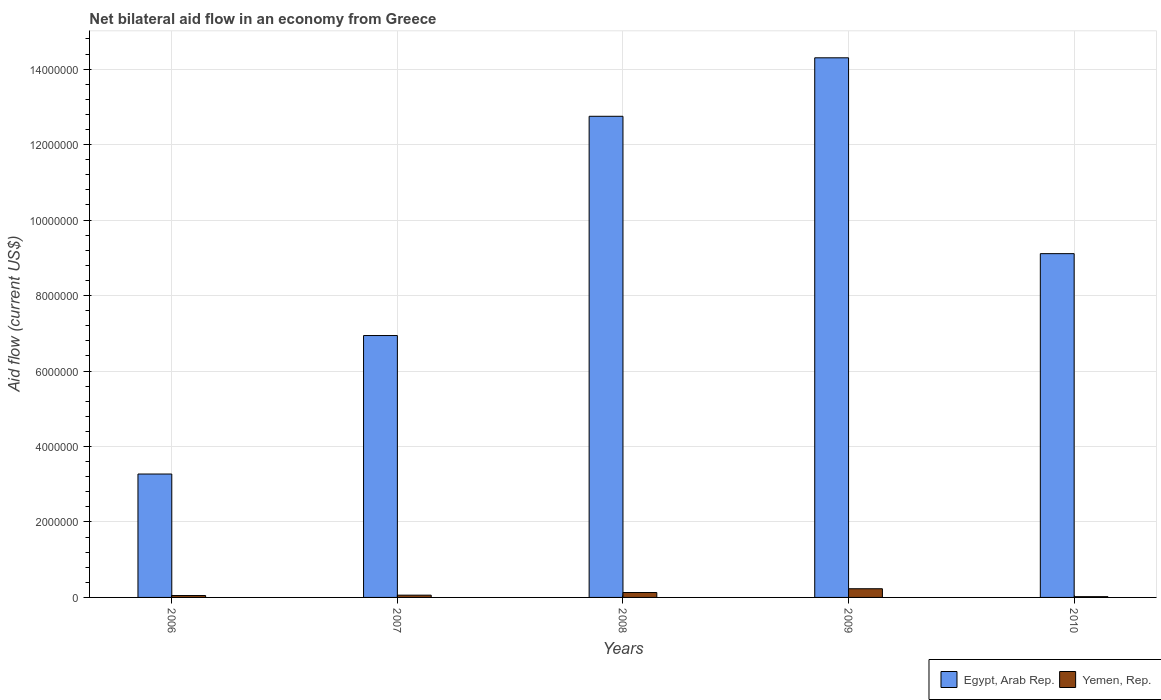How many different coloured bars are there?
Make the answer very short. 2. How many groups of bars are there?
Your answer should be compact. 5. Are the number of bars per tick equal to the number of legend labels?
Your response must be concise. Yes. How many bars are there on the 1st tick from the left?
Your response must be concise. 2. What is the label of the 4th group of bars from the left?
Offer a very short reply. 2009. What is the net bilateral aid flow in Egypt, Arab Rep. in 2008?
Your response must be concise. 1.28e+07. Across all years, what is the maximum net bilateral aid flow in Egypt, Arab Rep.?
Make the answer very short. 1.43e+07. Across all years, what is the minimum net bilateral aid flow in Egypt, Arab Rep.?
Offer a terse response. 3.27e+06. In which year was the net bilateral aid flow in Egypt, Arab Rep. maximum?
Offer a very short reply. 2009. In which year was the net bilateral aid flow in Egypt, Arab Rep. minimum?
Ensure brevity in your answer.  2006. What is the total net bilateral aid flow in Egypt, Arab Rep. in the graph?
Your answer should be compact. 4.64e+07. What is the difference between the net bilateral aid flow in Egypt, Arab Rep. in 2007 and that in 2009?
Offer a very short reply. -7.36e+06. What is the difference between the net bilateral aid flow in Yemen, Rep. in 2008 and the net bilateral aid flow in Egypt, Arab Rep. in 2010?
Offer a very short reply. -8.98e+06. What is the average net bilateral aid flow in Yemen, Rep. per year?
Give a very brief answer. 9.80e+04. In the year 2009, what is the difference between the net bilateral aid flow in Egypt, Arab Rep. and net bilateral aid flow in Yemen, Rep.?
Your answer should be very brief. 1.41e+07. In how many years, is the net bilateral aid flow in Yemen, Rep. greater than 3600000 US$?
Make the answer very short. 0. What is the ratio of the net bilateral aid flow in Egypt, Arab Rep. in 2007 to that in 2008?
Ensure brevity in your answer.  0.54. What is the difference between the highest and the second highest net bilateral aid flow in Yemen, Rep.?
Make the answer very short. 1.00e+05. In how many years, is the net bilateral aid flow in Yemen, Rep. greater than the average net bilateral aid flow in Yemen, Rep. taken over all years?
Ensure brevity in your answer.  2. Is the sum of the net bilateral aid flow in Egypt, Arab Rep. in 2006 and 2008 greater than the maximum net bilateral aid flow in Yemen, Rep. across all years?
Provide a short and direct response. Yes. What does the 2nd bar from the left in 2008 represents?
Ensure brevity in your answer.  Yemen, Rep. What does the 1st bar from the right in 2008 represents?
Your answer should be very brief. Yemen, Rep. How many years are there in the graph?
Give a very brief answer. 5. What is the difference between two consecutive major ticks on the Y-axis?
Provide a succinct answer. 2.00e+06. Where does the legend appear in the graph?
Give a very brief answer. Bottom right. How are the legend labels stacked?
Your answer should be compact. Horizontal. What is the title of the graph?
Your response must be concise. Net bilateral aid flow in an economy from Greece. Does "Haiti" appear as one of the legend labels in the graph?
Make the answer very short. No. What is the label or title of the Y-axis?
Offer a terse response. Aid flow (current US$). What is the Aid flow (current US$) of Egypt, Arab Rep. in 2006?
Offer a very short reply. 3.27e+06. What is the Aid flow (current US$) in Egypt, Arab Rep. in 2007?
Provide a short and direct response. 6.94e+06. What is the Aid flow (current US$) of Egypt, Arab Rep. in 2008?
Ensure brevity in your answer.  1.28e+07. What is the Aid flow (current US$) in Egypt, Arab Rep. in 2009?
Keep it short and to the point. 1.43e+07. What is the Aid flow (current US$) in Yemen, Rep. in 2009?
Your answer should be very brief. 2.30e+05. What is the Aid flow (current US$) in Egypt, Arab Rep. in 2010?
Give a very brief answer. 9.11e+06. Across all years, what is the maximum Aid flow (current US$) in Egypt, Arab Rep.?
Your answer should be compact. 1.43e+07. Across all years, what is the maximum Aid flow (current US$) of Yemen, Rep.?
Offer a very short reply. 2.30e+05. Across all years, what is the minimum Aid flow (current US$) of Egypt, Arab Rep.?
Offer a terse response. 3.27e+06. What is the total Aid flow (current US$) in Egypt, Arab Rep. in the graph?
Offer a very short reply. 4.64e+07. What is the total Aid flow (current US$) of Yemen, Rep. in the graph?
Your response must be concise. 4.90e+05. What is the difference between the Aid flow (current US$) in Egypt, Arab Rep. in 2006 and that in 2007?
Provide a short and direct response. -3.67e+06. What is the difference between the Aid flow (current US$) in Egypt, Arab Rep. in 2006 and that in 2008?
Ensure brevity in your answer.  -9.48e+06. What is the difference between the Aid flow (current US$) of Yemen, Rep. in 2006 and that in 2008?
Your response must be concise. -8.00e+04. What is the difference between the Aid flow (current US$) in Egypt, Arab Rep. in 2006 and that in 2009?
Offer a very short reply. -1.10e+07. What is the difference between the Aid flow (current US$) of Egypt, Arab Rep. in 2006 and that in 2010?
Make the answer very short. -5.84e+06. What is the difference between the Aid flow (current US$) in Egypt, Arab Rep. in 2007 and that in 2008?
Ensure brevity in your answer.  -5.81e+06. What is the difference between the Aid flow (current US$) in Yemen, Rep. in 2007 and that in 2008?
Keep it short and to the point. -7.00e+04. What is the difference between the Aid flow (current US$) of Egypt, Arab Rep. in 2007 and that in 2009?
Provide a short and direct response. -7.36e+06. What is the difference between the Aid flow (current US$) in Yemen, Rep. in 2007 and that in 2009?
Your answer should be very brief. -1.70e+05. What is the difference between the Aid flow (current US$) of Egypt, Arab Rep. in 2007 and that in 2010?
Your answer should be very brief. -2.17e+06. What is the difference between the Aid flow (current US$) of Yemen, Rep. in 2007 and that in 2010?
Your answer should be compact. 4.00e+04. What is the difference between the Aid flow (current US$) in Egypt, Arab Rep. in 2008 and that in 2009?
Make the answer very short. -1.55e+06. What is the difference between the Aid flow (current US$) of Egypt, Arab Rep. in 2008 and that in 2010?
Offer a very short reply. 3.64e+06. What is the difference between the Aid flow (current US$) of Egypt, Arab Rep. in 2009 and that in 2010?
Your answer should be very brief. 5.19e+06. What is the difference between the Aid flow (current US$) of Egypt, Arab Rep. in 2006 and the Aid flow (current US$) of Yemen, Rep. in 2007?
Provide a succinct answer. 3.21e+06. What is the difference between the Aid flow (current US$) in Egypt, Arab Rep. in 2006 and the Aid flow (current US$) in Yemen, Rep. in 2008?
Offer a terse response. 3.14e+06. What is the difference between the Aid flow (current US$) of Egypt, Arab Rep. in 2006 and the Aid flow (current US$) of Yemen, Rep. in 2009?
Give a very brief answer. 3.04e+06. What is the difference between the Aid flow (current US$) of Egypt, Arab Rep. in 2006 and the Aid flow (current US$) of Yemen, Rep. in 2010?
Provide a succinct answer. 3.25e+06. What is the difference between the Aid flow (current US$) in Egypt, Arab Rep. in 2007 and the Aid flow (current US$) in Yemen, Rep. in 2008?
Ensure brevity in your answer.  6.81e+06. What is the difference between the Aid flow (current US$) in Egypt, Arab Rep. in 2007 and the Aid flow (current US$) in Yemen, Rep. in 2009?
Provide a succinct answer. 6.71e+06. What is the difference between the Aid flow (current US$) of Egypt, Arab Rep. in 2007 and the Aid flow (current US$) of Yemen, Rep. in 2010?
Give a very brief answer. 6.92e+06. What is the difference between the Aid flow (current US$) of Egypt, Arab Rep. in 2008 and the Aid flow (current US$) of Yemen, Rep. in 2009?
Your answer should be very brief. 1.25e+07. What is the difference between the Aid flow (current US$) of Egypt, Arab Rep. in 2008 and the Aid flow (current US$) of Yemen, Rep. in 2010?
Your answer should be compact. 1.27e+07. What is the difference between the Aid flow (current US$) in Egypt, Arab Rep. in 2009 and the Aid flow (current US$) in Yemen, Rep. in 2010?
Your response must be concise. 1.43e+07. What is the average Aid flow (current US$) in Egypt, Arab Rep. per year?
Offer a terse response. 9.27e+06. What is the average Aid flow (current US$) of Yemen, Rep. per year?
Your answer should be compact. 9.80e+04. In the year 2006, what is the difference between the Aid flow (current US$) in Egypt, Arab Rep. and Aid flow (current US$) in Yemen, Rep.?
Ensure brevity in your answer.  3.22e+06. In the year 2007, what is the difference between the Aid flow (current US$) of Egypt, Arab Rep. and Aid flow (current US$) of Yemen, Rep.?
Your answer should be compact. 6.88e+06. In the year 2008, what is the difference between the Aid flow (current US$) in Egypt, Arab Rep. and Aid flow (current US$) in Yemen, Rep.?
Ensure brevity in your answer.  1.26e+07. In the year 2009, what is the difference between the Aid flow (current US$) of Egypt, Arab Rep. and Aid flow (current US$) of Yemen, Rep.?
Your answer should be compact. 1.41e+07. In the year 2010, what is the difference between the Aid flow (current US$) of Egypt, Arab Rep. and Aid flow (current US$) of Yemen, Rep.?
Your answer should be compact. 9.09e+06. What is the ratio of the Aid flow (current US$) of Egypt, Arab Rep. in 2006 to that in 2007?
Provide a succinct answer. 0.47. What is the ratio of the Aid flow (current US$) in Egypt, Arab Rep. in 2006 to that in 2008?
Provide a short and direct response. 0.26. What is the ratio of the Aid flow (current US$) of Yemen, Rep. in 2006 to that in 2008?
Keep it short and to the point. 0.38. What is the ratio of the Aid flow (current US$) of Egypt, Arab Rep. in 2006 to that in 2009?
Offer a terse response. 0.23. What is the ratio of the Aid flow (current US$) in Yemen, Rep. in 2006 to that in 2009?
Your response must be concise. 0.22. What is the ratio of the Aid flow (current US$) of Egypt, Arab Rep. in 2006 to that in 2010?
Make the answer very short. 0.36. What is the ratio of the Aid flow (current US$) of Yemen, Rep. in 2006 to that in 2010?
Make the answer very short. 2.5. What is the ratio of the Aid flow (current US$) of Egypt, Arab Rep. in 2007 to that in 2008?
Offer a very short reply. 0.54. What is the ratio of the Aid flow (current US$) of Yemen, Rep. in 2007 to that in 2008?
Keep it short and to the point. 0.46. What is the ratio of the Aid flow (current US$) of Egypt, Arab Rep. in 2007 to that in 2009?
Provide a succinct answer. 0.49. What is the ratio of the Aid flow (current US$) of Yemen, Rep. in 2007 to that in 2009?
Provide a succinct answer. 0.26. What is the ratio of the Aid flow (current US$) in Egypt, Arab Rep. in 2007 to that in 2010?
Make the answer very short. 0.76. What is the ratio of the Aid flow (current US$) of Yemen, Rep. in 2007 to that in 2010?
Your answer should be very brief. 3. What is the ratio of the Aid flow (current US$) in Egypt, Arab Rep. in 2008 to that in 2009?
Provide a succinct answer. 0.89. What is the ratio of the Aid flow (current US$) in Yemen, Rep. in 2008 to that in 2009?
Make the answer very short. 0.57. What is the ratio of the Aid flow (current US$) in Egypt, Arab Rep. in 2008 to that in 2010?
Offer a terse response. 1.4. What is the ratio of the Aid flow (current US$) in Egypt, Arab Rep. in 2009 to that in 2010?
Offer a terse response. 1.57. What is the difference between the highest and the second highest Aid flow (current US$) of Egypt, Arab Rep.?
Provide a short and direct response. 1.55e+06. What is the difference between the highest and the lowest Aid flow (current US$) of Egypt, Arab Rep.?
Offer a very short reply. 1.10e+07. 